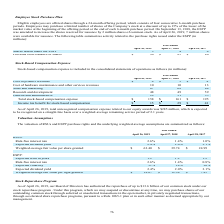From Netapp's financial document, Which years does the table provide information for the company's stock-based compensation expense? The document contains multiple relevant values: 2019, 2018, 2017. From the document: "April 26, 2019 April 27, 2018 April 28, 2017 April 26, 2019 April 27, 2018 April 28, 2017 April 26, 2019 April 27, 2018 April 28, 2017..." Also, What was the cost of product revenues in 2019? According to the financial document, 4 (in millions). The relevant text states: "Cost of product revenues $ 4 $ 3 $ 4..." Also, How many years did the sales and marketing expense exceed $60 million? Counting the relevant items in the document: 2019, 2018, 2017, I find 3 instances. The key data points involved are: 2017, 2018, 2019. Also, can you calculate: What would be the change in Research and development expense between 2017 and 2018? Based on the calculation: 49-59, the result is -10 (in millions). This is based on the information: "Research and development 48 49 59 Research and development 48 49 59..." The key data points involved are: 49, 59. Also, can you calculate: What would be the percentage change in General and administrative expense between 2018 and 2019? To answer this question, I need to perform calculations using the financial data. The calculation is: (29-31)/31, which equals -6.45 (percentage). This is based on the information: "General and administrative 29 31 35 General and administrative 29 31 35..." The key data points involved are: 29, 31. Also, What would be the total unrecognized compensation expense related to the company's equity awards? According to the financial document, $285 million. The relevant text states: "pensation expense related to our equity awards was $285 million, which is expected to be recognized on a straight-line basis over a weighted-average remaining serv..." 